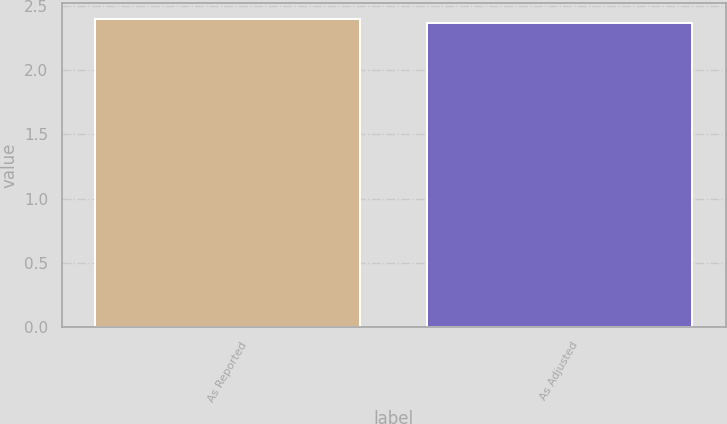<chart> <loc_0><loc_0><loc_500><loc_500><bar_chart><fcel>As Reported<fcel>As Adjusted<nl><fcel>2.4<fcel>2.37<nl></chart> 